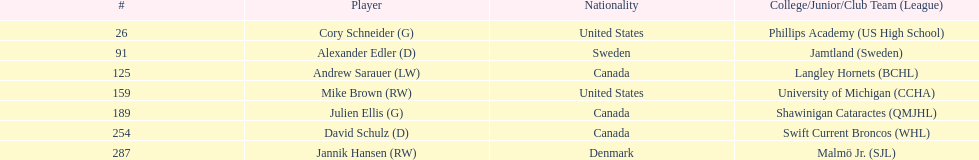What is the name of the last player on this chart? Jannik Hansen (RW). 